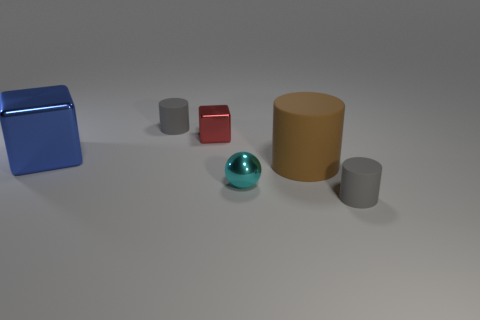There is a ball that is the same size as the red cube; what is it made of?
Your answer should be compact. Metal. There is a large shiny thing; does it have the same color as the rubber cylinder that is behind the large shiny thing?
Keep it short and to the point. No. Are there fewer large blue shiny cubes behind the blue shiny thing than blue objects?
Provide a succinct answer. Yes. How many large red rubber objects are there?
Provide a short and direct response. 0. What is the shape of the gray object that is on the right side of the small gray cylinder that is behind the large blue object?
Keep it short and to the point. Cylinder. There is a large brown object; how many small spheres are behind it?
Your answer should be very brief. 0. Is the blue object made of the same material as the small gray cylinder that is behind the tiny cyan shiny thing?
Your answer should be compact. No. Is there a shiny thing that has the same size as the brown matte object?
Your answer should be compact. Yes. Is the number of small gray cylinders to the left of the tiny cyan object the same as the number of spheres?
Offer a very short reply. Yes. What is the size of the cyan metallic ball?
Keep it short and to the point. Small. 